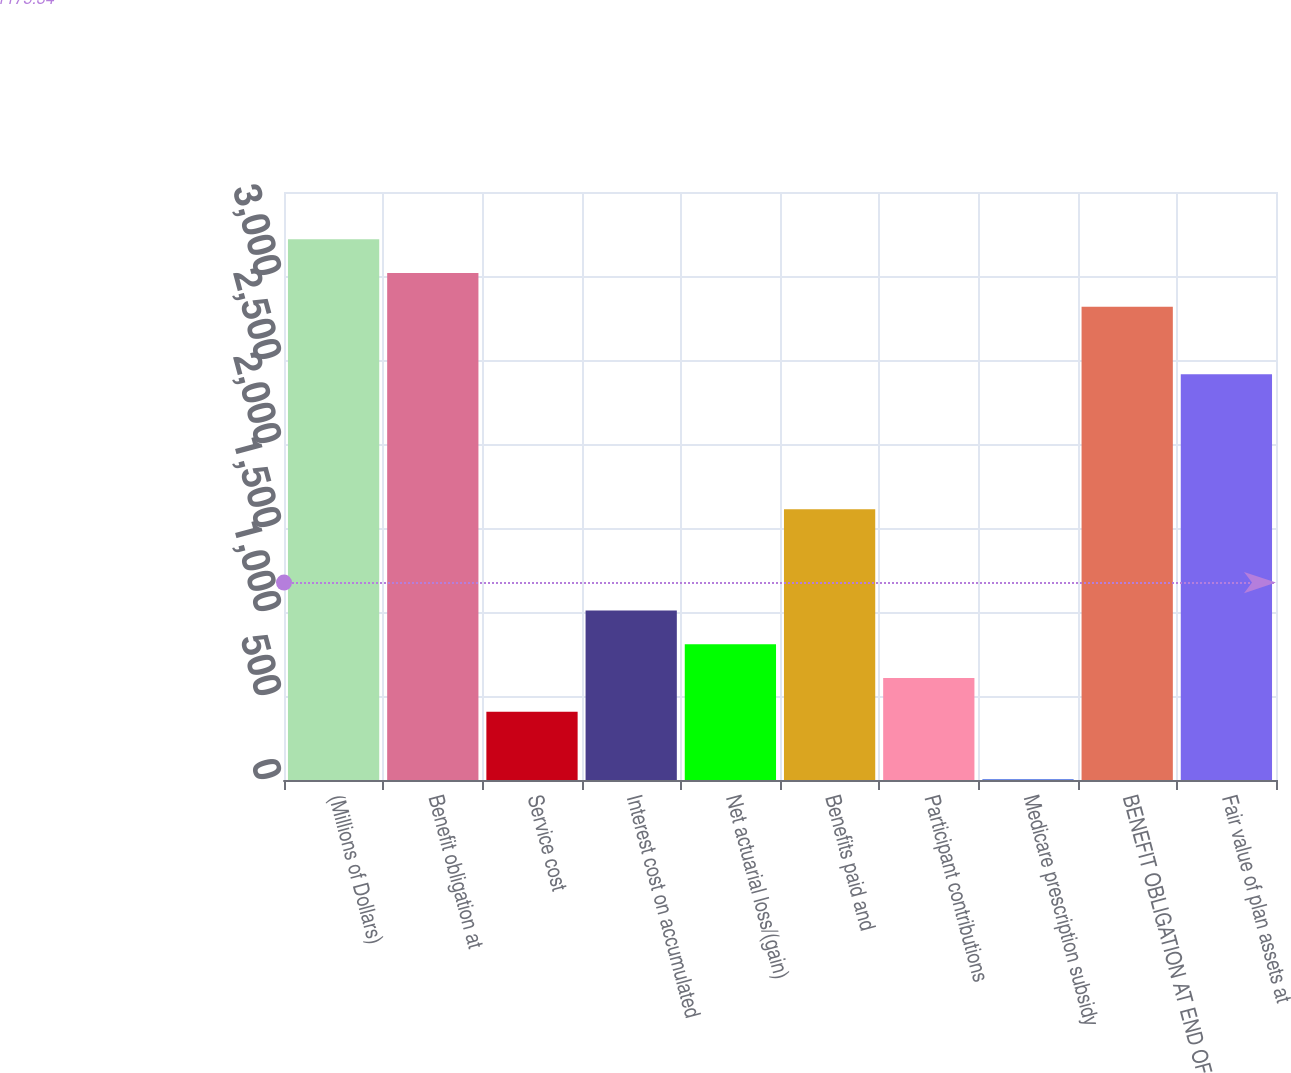Convert chart. <chart><loc_0><loc_0><loc_500><loc_500><bar_chart><fcel>(Millions of Dollars)<fcel>Benefit obligation at<fcel>Service cost<fcel>Interest cost on accumulated<fcel>Net actuarial loss/(gain)<fcel>Benefits paid and<fcel>Participant contributions<fcel>Medicare prescription subsidy<fcel>BENEFIT OBLIGATION AT END OF<fcel>Fair value of plan assets at<nl><fcel>3218.4<fcel>3017.5<fcel>405.8<fcel>1008.5<fcel>807.6<fcel>1611.2<fcel>606.7<fcel>4<fcel>2816.6<fcel>2414.8<nl></chart> 